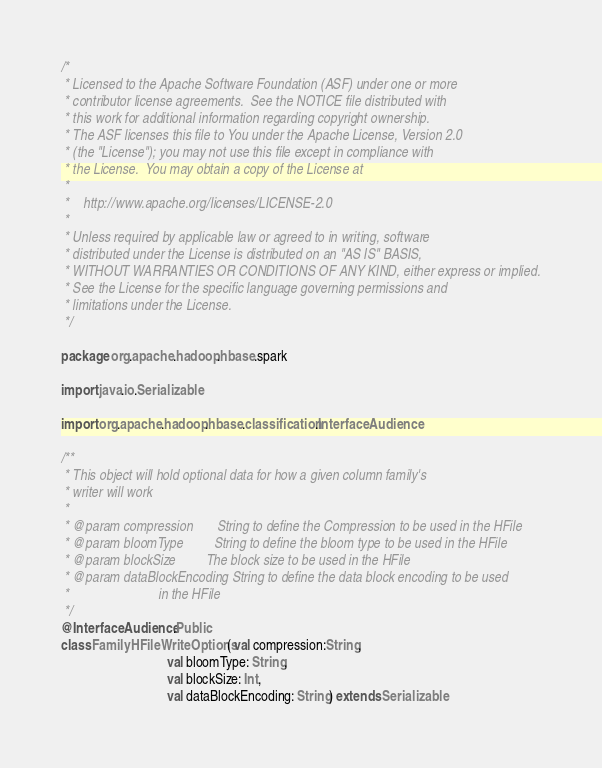<code> <loc_0><loc_0><loc_500><loc_500><_Scala_>/*
 * Licensed to the Apache Software Foundation (ASF) under one or more
 * contributor license agreements.  See the NOTICE file distributed with
 * this work for additional information regarding copyright ownership.
 * The ASF licenses this file to You under the Apache License, Version 2.0
 * (the "License"); you may not use this file except in compliance with
 * the License.  You may obtain a copy of the License at
 *
 *    http://www.apache.org/licenses/LICENSE-2.0
 *
 * Unless required by applicable law or agreed to in writing, software
 * distributed under the License is distributed on an "AS IS" BASIS,
 * WITHOUT WARRANTIES OR CONDITIONS OF ANY KIND, either express or implied.
 * See the License for the specific language governing permissions and
 * limitations under the License.
 */

package org.apache.hadoop.hbase.spark

import java.io.Serializable

import org.apache.hadoop.hbase.classification.InterfaceAudience

/**
 * This object will hold optional data for how a given column family's
 * writer will work
 *
 * @param compression       String to define the Compression to be used in the HFile
 * @param bloomType         String to define the bloom type to be used in the HFile
 * @param blockSize         The block size to be used in the HFile
 * @param dataBlockEncoding String to define the data block encoding to be used
 *                          in the HFile
 */
@InterfaceAudience.Public
class FamilyHFileWriteOptions( val compression:String,
                               val bloomType: String,
                               val blockSize: Int,
                               val dataBlockEncoding: String) extends Serializable
</code> 